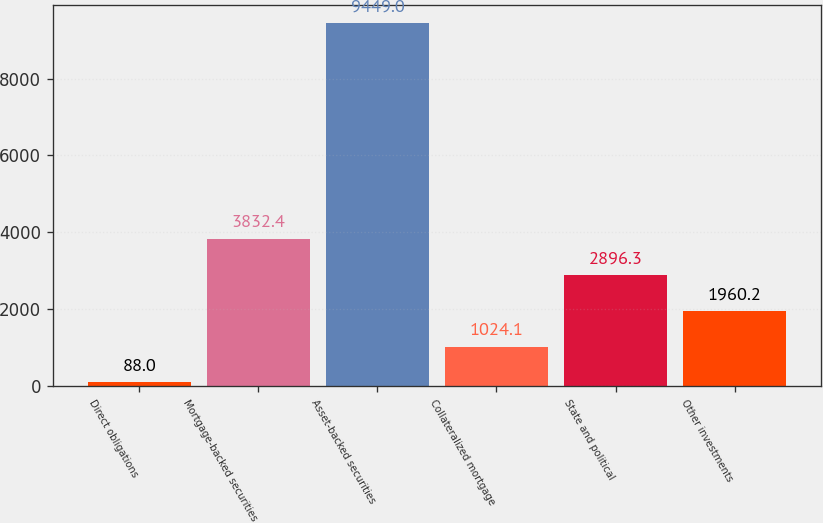<chart> <loc_0><loc_0><loc_500><loc_500><bar_chart><fcel>Direct obligations<fcel>Mortgage-backed securities<fcel>Asset-backed securities<fcel>Collateralized mortgage<fcel>State and political<fcel>Other investments<nl><fcel>88<fcel>3832.4<fcel>9449<fcel>1024.1<fcel>2896.3<fcel>1960.2<nl></chart> 